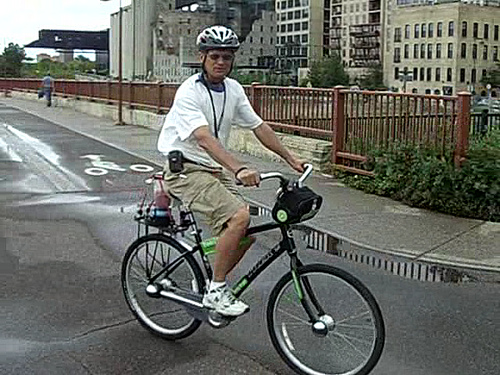What is above the bicycle?
A. man
B. cat
C. baby
D. old woman
Answer with the option's letter from the given choices directly. A 